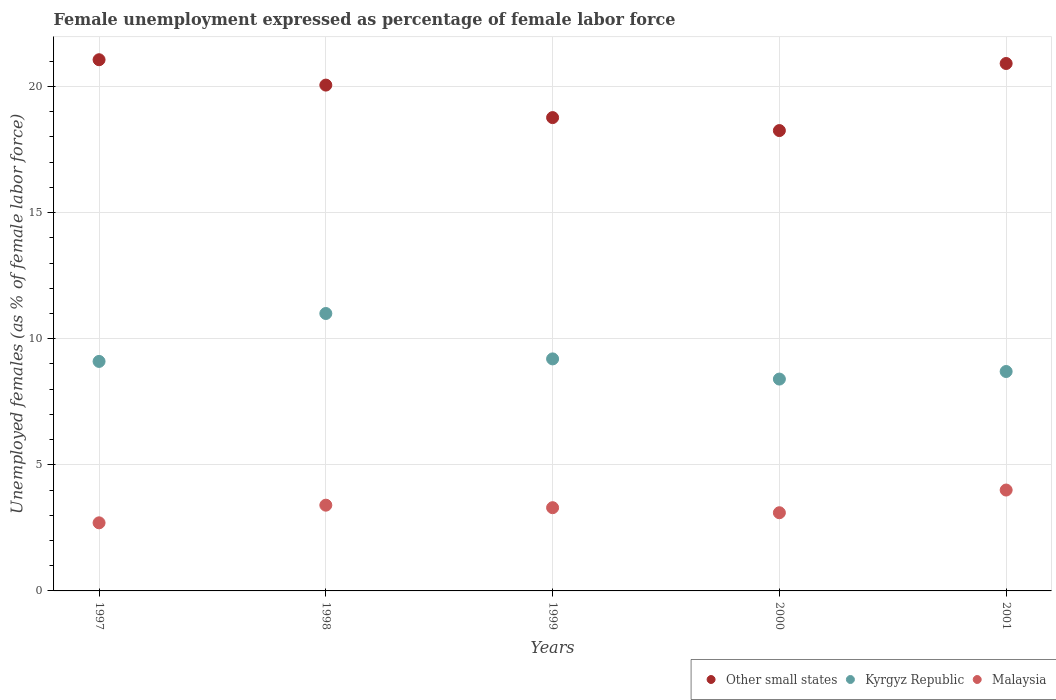How many different coloured dotlines are there?
Offer a very short reply. 3. Is the number of dotlines equal to the number of legend labels?
Your response must be concise. Yes. What is the unemployment in females in in Malaysia in 1997?
Offer a terse response. 2.7. Across all years, what is the maximum unemployment in females in in Malaysia?
Your response must be concise. 4. Across all years, what is the minimum unemployment in females in in Malaysia?
Provide a short and direct response. 2.7. In which year was the unemployment in females in in Kyrgyz Republic minimum?
Keep it short and to the point. 2000. What is the total unemployment in females in in Other small states in the graph?
Make the answer very short. 99.05. What is the difference between the unemployment in females in in Other small states in 1998 and that in 1999?
Provide a succinct answer. 1.29. What is the difference between the unemployment in females in in Malaysia in 2000 and the unemployment in females in in Kyrgyz Republic in 2001?
Give a very brief answer. -5.6. What is the average unemployment in females in in Kyrgyz Republic per year?
Your answer should be very brief. 9.28. In the year 1999, what is the difference between the unemployment in females in in Other small states and unemployment in females in in Malaysia?
Your answer should be compact. 15.47. In how many years, is the unemployment in females in in Malaysia greater than 14 %?
Keep it short and to the point. 0. What is the ratio of the unemployment in females in in Other small states in 1999 to that in 2000?
Provide a succinct answer. 1.03. Is the unemployment in females in in Kyrgyz Republic in 1997 less than that in 1998?
Ensure brevity in your answer.  Yes. Is the difference between the unemployment in females in in Other small states in 1998 and 1999 greater than the difference between the unemployment in females in in Malaysia in 1998 and 1999?
Offer a terse response. Yes. What is the difference between the highest and the second highest unemployment in females in in Kyrgyz Republic?
Provide a succinct answer. 1.8. What is the difference between the highest and the lowest unemployment in females in in Kyrgyz Republic?
Keep it short and to the point. 2.6. In how many years, is the unemployment in females in in Other small states greater than the average unemployment in females in in Other small states taken over all years?
Your response must be concise. 3. Does the unemployment in females in in Malaysia monotonically increase over the years?
Ensure brevity in your answer.  No. How many years are there in the graph?
Provide a succinct answer. 5. Does the graph contain grids?
Your response must be concise. Yes. How many legend labels are there?
Offer a very short reply. 3. How are the legend labels stacked?
Give a very brief answer. Horizontal. What is the title of the graph?
Offer a terse response. Female unemployment expressed as percentage of female labor force. What is the label or title of the Y-axis?
Offer a terse response. Unemployed females (as % of female labor force). What is the Unemployed females (as % of female labor force) of Other small states in 1997?
Provide a short and direct response. 21.06. What is the Unemployed females (as % of female labor force) in Kyrgyz Republic in 1997?
Give a very brief answer. 9.1. What is the Unemployed females (as % of female labor force) of Malaysia in 1997?
Offer a very short reply. 2.7. What is the Unemployed females (as % of female labor force) in Other small states in 1998?
Keep it short and to the point. 20.06. What is the Unemployed females (as % of female labor force) in Malaysia in 1998?
Ensure brevity in your answer.  3.4. What is the Unemployed females (as % of female labor force) of Other small states in 1999?
Offer a terse response. 18.77. What is the Unemployed females (as % of female labor force) in Kyrgyz Republic in 1999?
Offer a very short reply. 9.2. What is the Unemployed females (as % of female labor force) in Malaysia in 1999?
Offer a terse response. 3.3. What is the Unemployed females (as % of female labor force) of Other small states in 2000?
Make the answer very short. 18.25. What is the Unemployed females (as % of female labor force) of Kyrgyz Republic in 2000?
Offer a very short reply. 8.4. What is the Unemployed females (as % of female labor force) in Malaysia in 2000?
Ensure brevity in your answer.  3.1. What is the Unemployed females (as % of female labor force) of Other small states in 2001?
Provide a short and direct response. 20.91. What is the Unemployed females (as % of female labor force) of Kyrgyz Republic in 2001?
Make the answer very short. 8.7. What is the Unemployed females (as % of female labor force) of Malaysia in 2001?
Keep it short and to the point. 4. Across all years, what is the maximum Unemployed females (as % of female labor force) of Other small states?
Your answer should be compact. 21.06. Across all years, what is the maximum Unemployed females (as % of female labor force) in Kyrgyz Republic?
Ensure brevity in your answer.  11. Across all years, what is the minimum Unemployed females (as % of female labor force) of Other small states?
Offer a very short reply. 18.25. Across all years, what is the minimum Unemployed females (as % of female labor force) of Kyrgyz Republic?
Provide a succinct answer. 8.4. Across all years, what is the minimum Unemployed females (as % of female labor force) of Malaysia?
Your answer should be compact. 2.7. What is the total Unemployed females (as % of female labor force) in Other small states in the graph?
Provide a short and direct response. 99.05. What is the total Unemployed females (as % of female labor force) of Kyrgyz Republic in the graph?
Your answer should be very brief. 46.4. What is the total Unemployed females (as % of female labor force) in Malaysia in the graph?
Make the answer very short. 16.5. What is the difference between the Unemployed females (as % of female labor force) of Other small states in 1997 and that in 1998?
Provide a succinct answer. 1.01. What is the difference between the Unemployed females (as % of female labor force) of Malaysia in 1997 and that in 1998?
Make the answer very short. -0.7. What is the difference between the Unemployed females (as % of female labor force) in Other small states in 1997 and that in 1999?
Ensure brevity in your answer.  2.29. What is the difference between the Unemployed females (as % of female labor force) of Kyrgyz Republic in 1997 and that in 1999?
Give a very brief answer. -0.1. What is the difference between the Unemployed females (as % of female labor force) of Malaysia in 1997 and that in 1999?
Your answer should be very brief. -0.6. What is the difference between the Unemployed females (as % of female labor force) of Other small states in 1997 and that in 2000?
Your answer should be compact. 2.81. What is the difference between the Unemployed females (as % of female labor force) in Kyrgyz Republic in 1997 and that in 2000?
Offer a terse response. 0.7. What is the difference between the Unemployed females (as % of female labor force) of Other small states in 1997 and that in 2001?
Offer a very short reply. 0.15. What is the difference between the Unemployed females (as % of female labor force) in Malaysia in 1997 and that in 2001?
Offer a very short reply. -1.3. What is the difference between the Unemployed females (as % of female labor force) of Other small states in 1998 and that in 1999?
Your answer should be very brief. 1.29. What is the difference between the Unemployed females (as % of female labor force) of Kyrgyz Republic in 1998 and that in 1999?
Your answer should be very brief. 1.8. What is the difference between the Unemployed females (as % of female labor force) in Malaysia in 1998 and that in 1999?
Your answer should be very brief. 0.1. What is the difference between the Unemployed females (as % of female labor force) of Other small states in 1998 and that in 2000?
Offer a terse response. 1.8. What is the difference between the Unemployed females (as % of female labor force) of Kyrgyz Republic in 1998 and that in 2000?
Offer a very short reply. 2.6. What is the difference between the Unemployed females (as % of female labor force) in Other small states in 1998 and that in 2001?
Your response must be concise. -0.86. What is the difference between the Unemployed females (as % of female labor force) in Other small states in 1999 and that in 2000?
Ensure brevity in your answer.  0.51. What is the difference between the Unemployed females (as % of female labor force) of Malaysia in 1999 and that in 2000?
Provide a short and direct response. 0.2. What is the difference between the Unemployed females (as % of female labor force) of Other small states in 1999 and that in 2001?
Your answer should be very brief. -2.15. What is the difference between the Unemployed females (as % of female labor force) in Kyrgyz Republic in 1999 and that in 2001?
Ensure brevity in your answer.  0.5. What is the difference between the Unemployed females (as % of female labor force) of Other small states in 2000 and that in 2001?
Make the answer very short. -2.66. What is the difference between the Unemployed females (as % of female labor force) of Other small states in 1997 and the Unemployed females (as % of female labor force) of Kyrgyz Republic in 1998?
Your answer should be very brief. 10.06. What is the difference between the Unemployed females (as % of female labor force) of Other small states in 1997 and the Unemployed females (as % of female labor force) of Malaysia in 1998?
Your response must be concise. 17.66. What is the difference between the Unemployed females (as % of female labor force) in Kyrgyz Republic in 1997 and the Unemployed females (as % of female labor force) in Malaysia in 1998?
Make the answer very short. 5.7. What is the difference between the Unemployed females (as % of female labor force) of Other small states in 1997 and the Unemployed females (as % of female labor force) of Kyrgyz Republic in 1999?
Your answer should be compact. 11.86. What is the difference between the Unemployed females (as % of female labor force) in Other small states in 1997 and the Unemployed females (as % of female labor force) in Malaysia in 1999?
Provide a succinct answer. 17.76. What is the difference between the Unemployed females (as % of female labor force) in Other small states in 1997 and the Unemployed females (as % of female labor force) in Kyrgyz Republic in 2000?
Give a very brief answer. 12.66. What is the difference between the Unemployed females (as % of female labor force) in Other small states in 1997 and the Unemployed females (as % of female labor force) in Malaysia in 2000?
Give a very brief answer. 17.96. What is the difference between the Unemployed females (as % of female labor force) of Other small states in 1997 and the Unemployed females (as % of female labor force) of Kyrgyz Republic in 2001?
Provide a succinct answer. 12.36. What is the difference between the Unemployed females (as % of female labor force) of Other small states in 1997 and the Unemployed females (as % of female labor force) of Malaysia in 2001?
Your response must be concise. 17.06. What is the difference between the Unemployed females (as % of female labor force) of Kyrgyz Republic in 1997 and the Unemployed females (as % of female labor force) of Malaysia in 2001?
Provide a succinct answer. 5.1. What is the difference between the Unemployed females (as % of female labor force) in Other small states in 1998 and the Unemployed females (as % of female labor force) in Kyrgyz Republic in 1999?
Offer a terse response. 10.86. What is the difference between the Unemployed females (as % of female labor force) in Other small states in 1998 and the Unemployed females (as % of female labor force) in Malaysia in 1999?
Offer a terse response. 16.76. What is the difference between the Unemployed females (as % of female labor force) of Kyrgyz Republic in 1998 and the Unemployed females (as % of female labor force) of Malaysia in 1999?
Offer a terse response. 7.7. What is the difference between the Unemployed females (as % of female labor force) of Other small states in 1998 and the Unemployed females (as % of female labor force) of Kyrgyz Republic in 2000?
Give a very brief answer. 11.66. What is the difference between the Unemployed females (as % of female labor force) in Other small states in 1998 and the Unemployed females (as % of female labor force) in Malaysia in 2000?
Provide a succinct answer. 16.96. What is the difference between the Unemployed females (as % of female labor force) of Other small states in 1998 and the Unemployed females (as % of female labor force) of Kyrgyz Republic in 2001?
Make the answer very short. 11.36. What is the difference between the Unemployed females (as % of female labor force) of Other small states in 1998 and the Unemployed females (as % of female labor force) of Malaysia in 2001?
Offer a terse response. 16.06. What is the difference between the Unemployed females (as % of female labor force) of Kyrgyz Republic in 1998 and the Unemployed females (as % of female labor force) of Malaysia in 2001?
Make the answer very short. 7. What is the difference between the Unemployed females (as % of female labor force) in Other small states in 1999 and the Unemployed females (as % of female labor force) in Kyrgyz Republic in 2000?
Give a very brief answer. 10.37. What is the difference between the Unemployed females (as % of female labor force) in Other small states in 1999 and the Unemployed females (as % of female labor force) in Malaysia in 2000?
Ensure brevity in your answer.  15.67. What is the difference between the Unemployed females (as % of female labor force) of Other small states in 1999 and the Unemployed females (as % of female labor force) of Kyrgyz Republic in 2001?
Your answer should be compact. 10.07. What is the difference between the Unemployed females (as % of female labor force) in Other small states in 1999 and the Unemployed females (as % of female labor force) in Malaysia in 2001?
Make the answer very short. 14.77. What is the difference between the Unemployed females (as % of female labor force) of Kyrgyz Republic in 1999 and the Unemployed females (as % of female labor force) of Malaysia in 2001?
Offer a very short reply. 5.2. What is the difference between the Unemployed females (as % of female labor force) in Other small states in 2000 and the Unemployed females (as % of female labor force) in Kyrgyz Republic in 2001?
Provide a succinct answer. 9.55. What is the difference between the Unemployed females (as % of female labor force) in Other small states in 2000 and the Unemployed females (as % of female labor force) in Malaysia in 2001?
Make the answer very short. 14.25. What is the average Unemployed females (as % of female labor force) in Other small states per year?
Offer a very short reply. 19.81. What is the average Unemployed females (as % of female labor force) of Kyrgyz Republic per year?
Keep it short and to the point. 9.28. What is the average Unemployed females (as % of female labor force) of Malaysia per year?
Your answer should be compact. 3.3. In the year 1997, what is the difference between the Unemployed females (as % of female labor force) in Other small states and Unemployed females (as % of female labor force) in Kyrgyz Republic?
Ensure brevity in your answer.  11.96. In the year 1997, what is the difference between the Unemployed females (as % of female labor force) of Other small states and Unemployed females (as % of female labor force) of Malaysia?
Ensure brevity in your answer.  18.36. In the year 1997, what is the difference between the Unemployed females (as % of female labor force) in Kyrgyz Republic and Unemployed females (as % of female labor force) in Malaysia?
Offer a very short reply. 6.4. In the year 1998, what is the difference between the Unemployed females (as % of female labor force) of Other small states and Unemployed females (as % of female labor force) of Kyrgyz Republic?
Keep it short and to the point. 9.06. In the year 1998, what is the difference between the Unemployed females (as % of female labor force) of Other small states and Unemployed females (as % of female labor force) of Malaysia?
Your answer should be compact. 16.66. In the year 1998, what is the difference between the Unemployed females (as % of female labor force) in Kyrgyz Republic and Unemployed females (as % of female labor force) in Malaysia?
Your response must be concise. 7.6. In the year 1999, what is the difference between the Unemployed females (as % of female labor force) in Other small states and Unemployed females (as % of female labor force) in Kyrgyz Republic?
Your answer should be compact. 9.57. In the year 1999, what is the difference between the Unemployed females (as % of female labor force) of Other small states and Unemployed females (as % of female labor force) of Malaysia?
Ensure brevity in your answer.  15.47. In the year 2000, what is the difference between the Unemployed females (as % of female labor force) in Other small states and Unemployed females (as % of female labor force) in Kyrgyz Republic?
Offer a terse response. 9.85. In the year 2000, what is the difference between the Unemployed females (as % of female labor force) in Other small states and Unemployed females (as % of female labor force) in Malaysia?
Your answer should be compact. 15.15. In the year 2000, what is the difference between the Unemployed females (as % of female labor force) in Kyrgyz Republic and Unemployed females (as % of female labor force) in Malaysia?
Keep it short and to the point. 5.3. In the year 2001, what is the difference between the Unemployed females (as % of female labor force) of Other small states and Unemployed females (as % of female labor force) of Kyrgyz Republic?
Your response must be concise. 12.21. In the year 2001, what is the difference between the Unemployed females (as % of female labor force) of Other small states and Unemployed females (as % of female labor force) of Malaysia?
Your answer should be very brief. 16.91. What is the ratio of the Unemployed females (as % of female labor force) of Other small states in 1997 to that in 1998?
Give a very brief answer. 1.05. What is the ratio of the Unemployed females (as % of female labor force) of Kyrgyz Republic in 1997 to that in 1998?
Make the answer very short. 0.83. What is the ratio of the Unemployed females (as % of female labor force) of Malaysia in 1997 to that in 1998?
Offer a terse response. 0.79. What is the ratio of the Unemployed females (as % of female labor force) in Other small states in 1997 to that in 1999?
Provide a succinct answer. 1.12. What is the ratio of the Unemployed females (as % of female labor force) of Malaysia in 1997 to that in 1999?
Give a very brief answer. 0.82. What is the ratio of the Unemployed females (as % of female labor force) in Other small states in 1997 to that in 2000?
Ensure brevity in your answer.  1.15. What is the ratio of the Unemployed females (as % of female labor force) of Malaysia in 1997 to that in 2000?
Provide a succinct answer. 0.87. What is the ratio of the Unemployed females (as % of female labor force) in Other small states in 1997 to that in 2001?
Make the answer very short. 1.01. What is the ratio of the Unemployed females (as % of female labor force) of Kyrgyz Republic in 1997 to that in 2001?
Your answer should be compact. 1.05. What is the ratio of the Unemployed females (as % of female labor force) in Malaysia in 1997 to that in 2001?
Keep it short and to the point. 0.68. What is the ratio of the Unemployed females (as % of female labor force) of Other small states in 1998 to that in 1999?
Ensure brevity in your answer.  1.07. What is the ratio of the Unemployed females (as % of female labor force) of Kyrgyz Republic in 1998 to that in 1999?
Keep it short and to the point. 1.2. What is the ratio of the Unemployed females (as % of female labor force) in Malaysia in 1998 to that in 1999?
Ensure brevity in your answer.  1.03. What is the ratio of the Unemployed females (as % of female labor force) of Other small states in 1998 to that in 2000?
Provide a succinct answer. 1.1. What is the ratio of the Unemployed females (as % of female labor force) in Kyrgyz Republic in 1998 to that in 2000?
Offer a terse response. 1.31. What is the ratio of the Unemployed females (as % of female labor force) of Malaysia in 1998 to that in 2000?
Ensure brevity in your answer.  1.1. What is the ratio of the Unemployed females (as % of female labor force) of Other small states in 1998 to that in 2001?
Your answer should be very brief. 0.96. What is the ratio of the Unemployed females (as % of female labor force) of Kyrgyz Republic in 1998 to that in 2001?
Give a very brief answer. 1.26. What is the ratio of the Unemployed females (as % of female labor force) of Other small states in 1999 to that in 2000?
Provide a succinct answer. 1.03. What is the ratio of the Unemployed females (as % of female labor force) in Kyrgyz Republic in 1999 to that in 2000?
Your answer should be very brief. 1.1. What is the ratio of the Unemployed females (as % of female labor force) of Malaysia in 1999 to that in 2000?
Your answer should be very brief. 1.06. What is the ratio of the Unemployed females (as % of female labor force) in Other small states in 1999 to that in 2001?
Ensure brevity in your answer.  0.9. What is the ratio of the Unemployed females (as % of female labor force) in Kyrgyz Republic in 1999 to that in 2001?
Give a very brief answer. 1.06. What is the ratio of the Unemployed females (as % of female labor force) in Malaysia in 1999 to that in 2001?
Keep it short and to the point. 0.82. What is the ratio of the Unemployed females (as % of female labor force) in Other small states in 2000 to that in 2001?
Your answer should be very brief. 0.87. What is the ratio of the Unemployed females (as % of female labor force) of Kyrgyz Republic in 2000 to that in 2001?
Offer a terse response. 0.97. What is the ratio of the Unemployed females (as % of female labor force) in Malaysia in 2000 to that in 2001?
Ensure brevity in your answer.  0.78. What is the difference between the highest and the second highest Unemployed females (as % of female labor force) in Other small states?
Give a very brief answer. 0.15. What is the difference between the highest and the lowest Unemployed females (as % of female labor force) of Other small states?
Give a very brief answer. 2.81. What is the difference between the highest and the lowest Unemployed females (as % of female labor force) of Kyrgyz Republic?
Your answer should be compact. 2.6. What is the difference between the highest and the lowest Unemployed females (as % of female labor force) of Malaysia?
Keep it short and to the point. 1.3. 